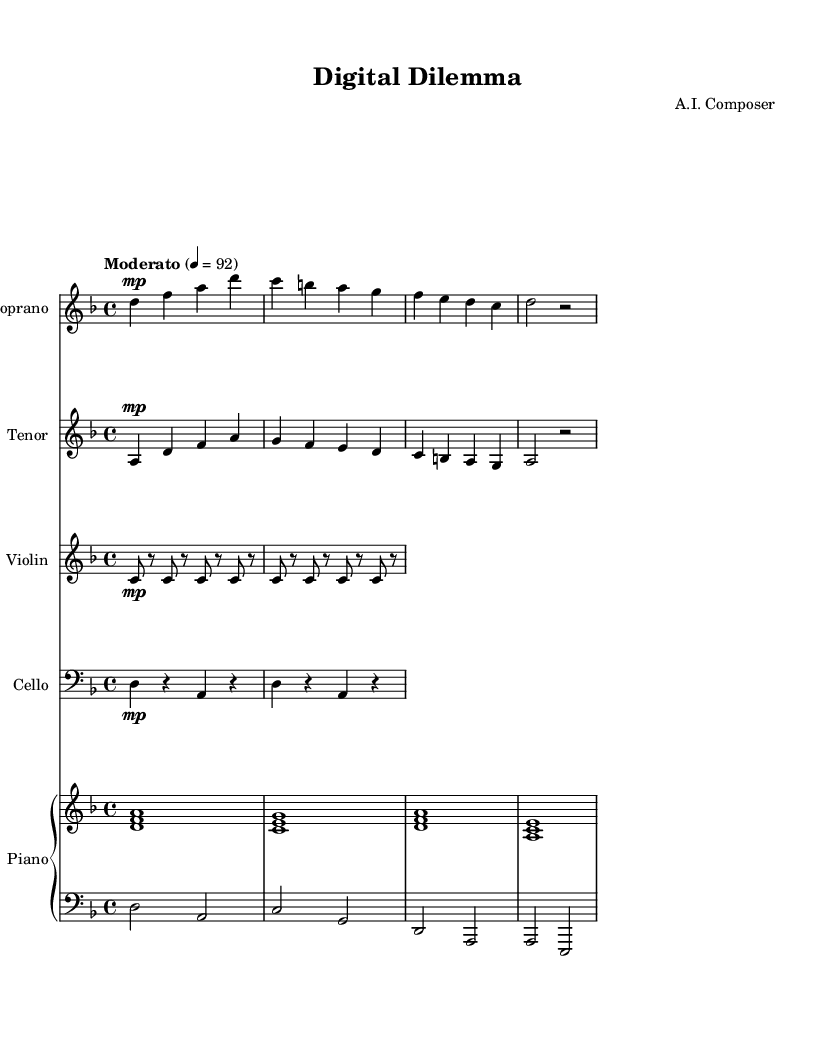What is the key signature of this music? The key signature is D minor, as indicated by the presence of one flat (B flat) on the left side of the staff.
Answer: D minor What is the time signature of this music? The time signature is 4/4, shown at the beginning of the score as a fraction that indicates four beats per measure, with the quarter note getting one beat.
Answer: 4/4 What is the tempo marking of this piece? The tempo marking indicates "Moderato" with a speed of 92 beats per minute, as specified in the score.
Answer: Moderato, 92 How many instruments are used in this opera score? The score includes five instruments: soprano, tenor, violin, cello, and piano (divided into right and left hands), totaling five distinct parts.
Answer: Five What is the dynamic marking for the soprano and tenor parts? Both the soprano and tenor parts have the dynamic marking "mp," which stands for mezzo-piano, indicating a moderately soft volume.
Answer: mp What theme do the lyrics of the soprano and tenor convey? The lyrics reflect the theme of work-life balance in the digital age by addressing the constant presence of screens in our lives, suggesting a struggle with modern distractions.
Answer: Digital age, screens Which clef is used for the cello part? The cello part is written in the bass clef, identifiable by the clef symbol placed at the beginning of the cello staff.
Answer: Bass clef 